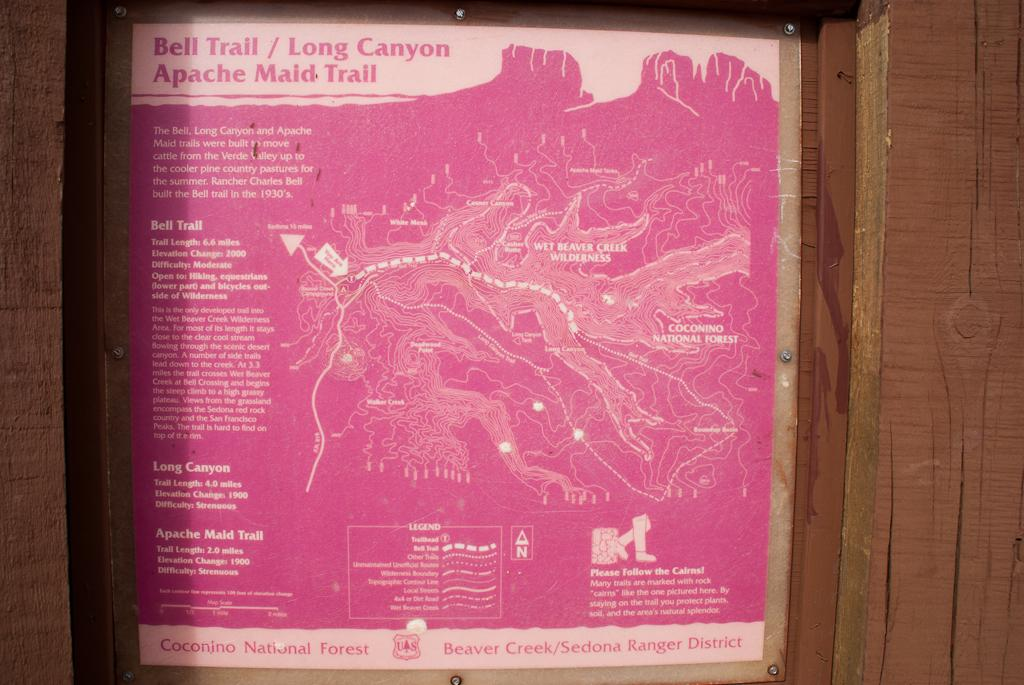Provide a one-sentence caption for the provided image. a pink poster stating Bell Trail/ Long Canyon Apache Maid Trail. 